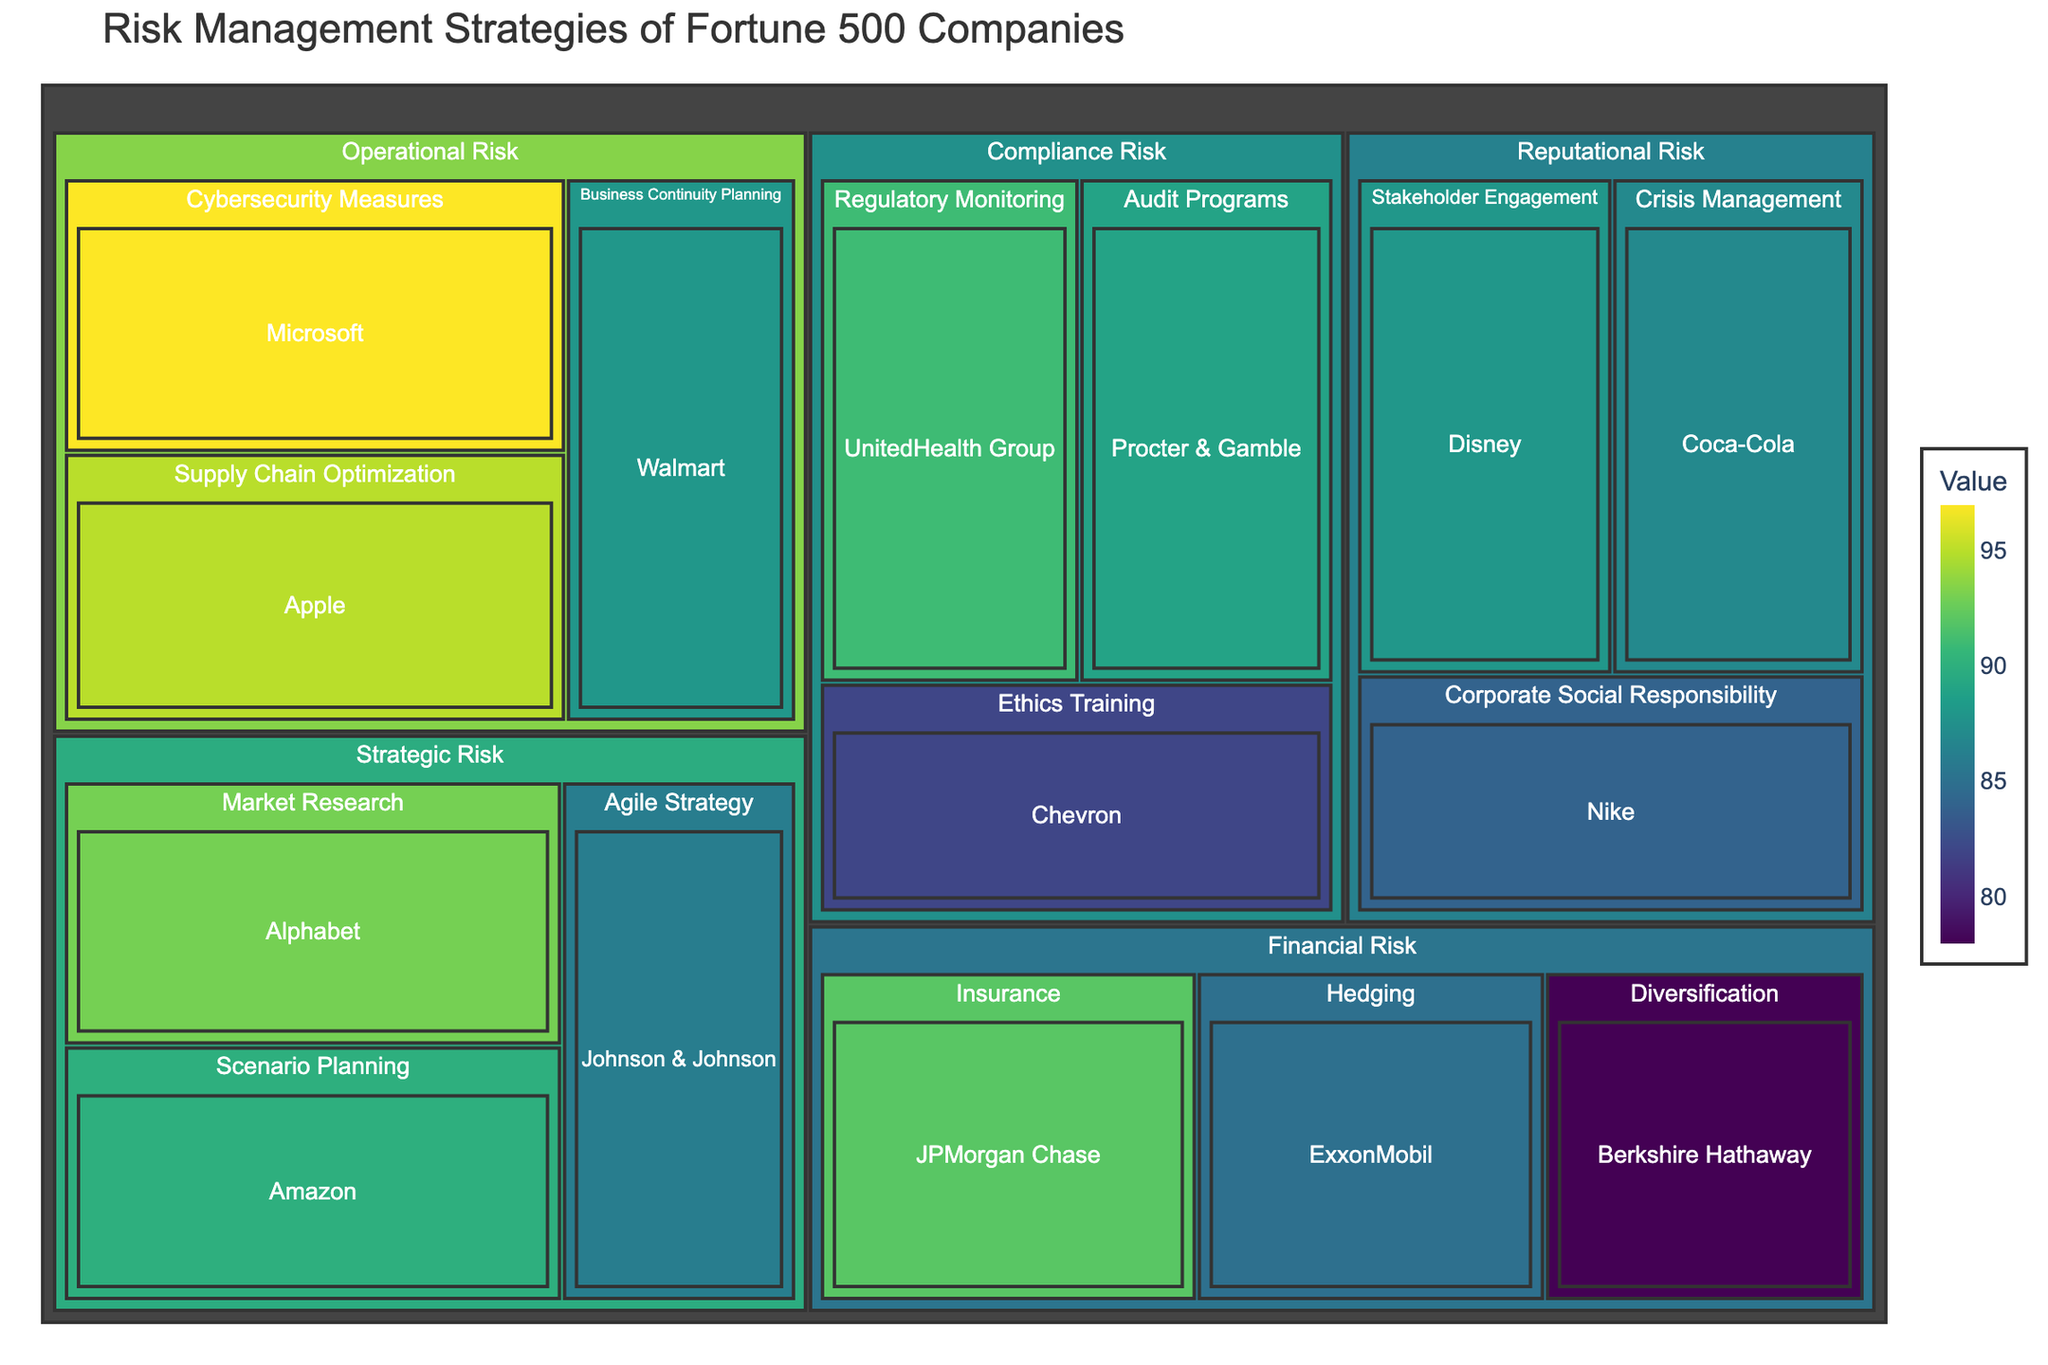What is the title of the treemap? The title can be found at the top of the treemap. It provides a summary or the main subject being visualized. In this case, the title is "Risk Management Strategies of Fortune 500 Companies".
Answer: Risk Management Strategies of Fortune 500 Companies Which company uses the "Market Research" mitigation approach? Look within the "Strategic Risk" category for the "Market Research" mitigation approach, and then find the company associated with it.
Answer: Alphabet How many companies employ mitigation approaches within “Operational Risk”? In the "Operational Risk" category, count the number of companies listed under any mitigation approach. There are "Business Continuity Planning" (1), "Supply Chain Optimization" (1), and "Cybersecurity Measures" (1). Summing these up gives 3 companies.
Answer: 3 Which risk type has the highest value for any mitigation approach? Find the highest value across all risk types and their approaches. The highest value is 97, found under "Operational Risk" for "Cybersecurity Measures".
Answer: Operational Risk What is the average value of the companies involved in "Compliance Risk"? Add up the values of all companies in "Compliance Risk" ("91 + 82 + 89") and divide by the number of companies (3). The sum is 262, and the average is 262 / 3 ≈ 87.33.
Answer: 87.33 Which mitigation approach has the highest average value within "Strategic Risk"? Calculate the average values for each approach within "Strategic Risk": "Scenario Planning" (90), "Market Research" (93), and "Agile Strategy" (86). Compare these averages to find the highest one, which is "Market Research" with an average value of 93.
Answer: Market Research How does the value for "Hedging" under "Financial Risk" compare to the value for "Crisis Management" under "Reputational Risk"? Find the values for both "Hedging" (85) and "Crisis Management" (87) and compare them. The value for “Hedging” is lower than that of “Crisis Management”.
Answer: Less What is the total value associated with "Reputational Risk"? Sum the values of all companies listed under “Reputational Risk”: "Crisis Management" (87), "Corporate Social Responsibility" (84), "Stakeholder Engagement" (88). The total is 259.
Answer: 259 Which risk type has the smallest range (difference between the highest and lowest values)? Calculate the range for each risk type by subtracting the smallest value from the highest within each type. "Financial Risk" (92 - 78 = 14), "Operational Risk" (97 - 88 = 9), "Strategic Risk" (93 - 86 = 7), "Compliance Risk" (91 - 82 = 9), "Reputational Risk" (88 - 84 = 4). The smallest range is within "Reputational Risk".
Answer: Reputational Risk 